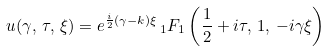<formula> <loc_0><loc_0><loc_500><loc_500>u ( \gamma , \, \tau , \, \xi ) = e ^ { \frac { i } { 2 } ( \gamma - k ) \xi } \, { _ { 1 } F _ { 1 } } \left ( \frac { 1 } { 2 } + i \tau , \, 1 , \, - i \gamma \xi \right )</formula> 